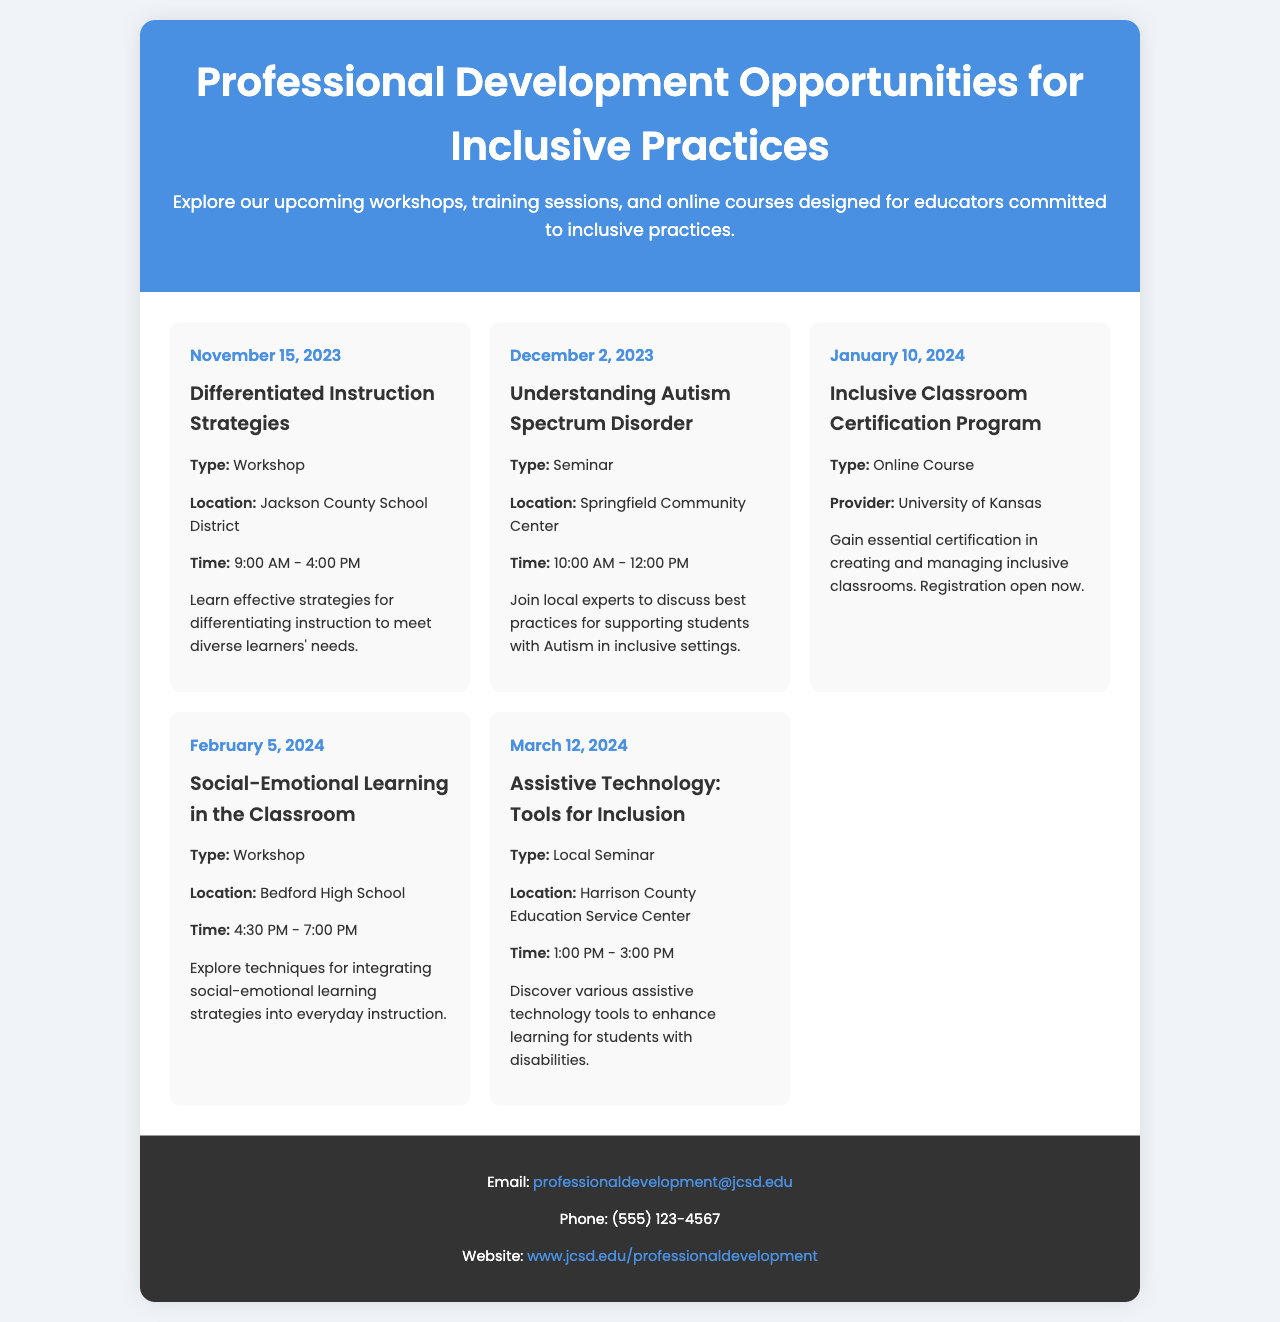What is the title of the first workshop? The title of the first workshop is located in the event section for November 15, 2023.
Answer: Differentiated Instruction Strategies When is the seminar on Understanding Autism Spectrum Disorder scheduled? The date can be found in the event for the Understanding Autism Spectrum Disorder seminar.
Answer: December 2, 2023 How long does the Inclusive Classroom Certification Program last? The document specifies the type of event, but it does not mention duration, thus this is not straightforward.
Answer: Not specified What is the location for the Social-Emotional Learning workshop? The location can be found in the event details for the workshop on February 5, 2024.
Answer: Bedford High School What is the main focus of the Assistive Technology seminar? The focus is summarized in the event details for the seminar on March 12, 2024.
Answer: Tools for Inclusion What time does the Differentiated Instruction Strategies workshop begin? The time is specified in the details of the workshop scheduled for November 15, 2023.
Answer: 9:00 AM How many events are listed in the brochure? The total number of events can be counted from the event sections in the calendar.
Answer: Five What type of professional development is offered on January 10, 2024? The document describes the type of the event scheduled for that date.
Answer: Online Course 